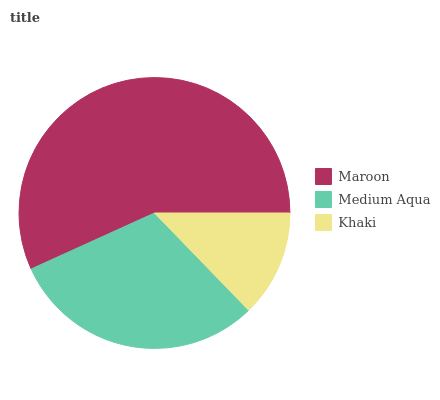Is Khaki the minimum?
Answer yes or no. Yes. Is Maroon the maximum?
Answer yes or no. Yes. Is Medium Aqua the minimum?
Answer yes or no. No. Is Medium Aqua the maximum?
Answer yes or no. No. Is Maroon greater than Medium Aqua?
Answer yes or no. Yes. Is Medium Aqua less than Maroon?
Answer yes or no. Yes. Is Medium Aqua greater than Maroon?
Answer yes or no. No. Is Maroon less than Medium Aqua?
Answer yes or no. No. Is Medium Aqua the high median?
Answer yes or no. Yes. Is Medium Aqua the low median?
Answer yes or no. Yes. Is Maroon the high median?
Answer yes or no. No. Is Maroon the low median?
Answer yes or no. No. 